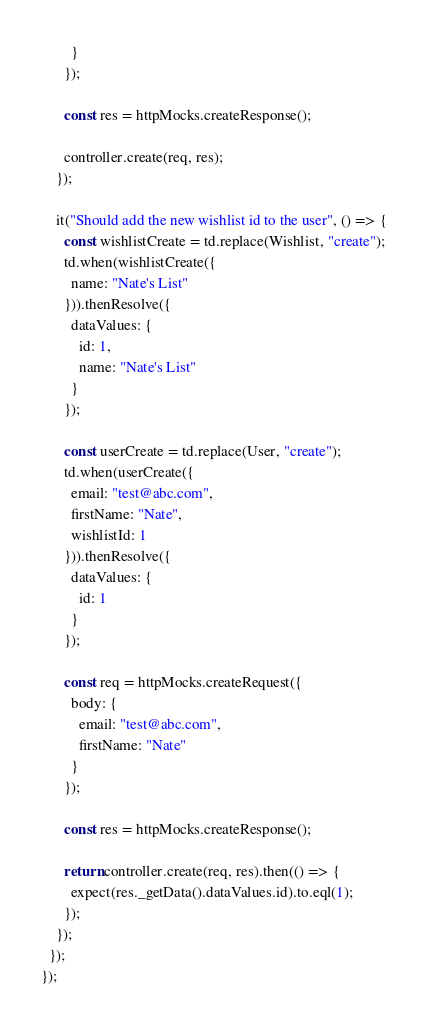Convert code to text. <code><loc_0><loc_0><loc_500><loc_500><_JavaScript_>        }
      });

      const res = httpMocks.createResponse();

      controller.create(req, res);
    });

    it("Should add the new wishlist id to the user", () => {
      const wishlistCreate = td.replace(Wishlist, "create");
      td.when(wishlistCreate({
        name: "Nate's List"
      })).thenResolve({
        dataValues: {
          id: 1,
          name: "Nate's List"
        }
      });

      const userCreate = td.replace(User, "create");
      td.when(userCreate({
        email: "test@abc.com",
        firstName: "Nate",
        wishlistId: 1
      })).thenResolve({
        dataValues: {
          id: 1
        }
      });

      const req = httpMocks.createRequest({
        body: {
          email: "test@abc.com",
          firstName: "Nate"
        }
      });

      const res = httpMocks.createResponse();

      return controller.create(req, res).then(() => {
        expect(res._getData().dataValues.id).to.eql(1);
      });
    });
  });
});</code> 